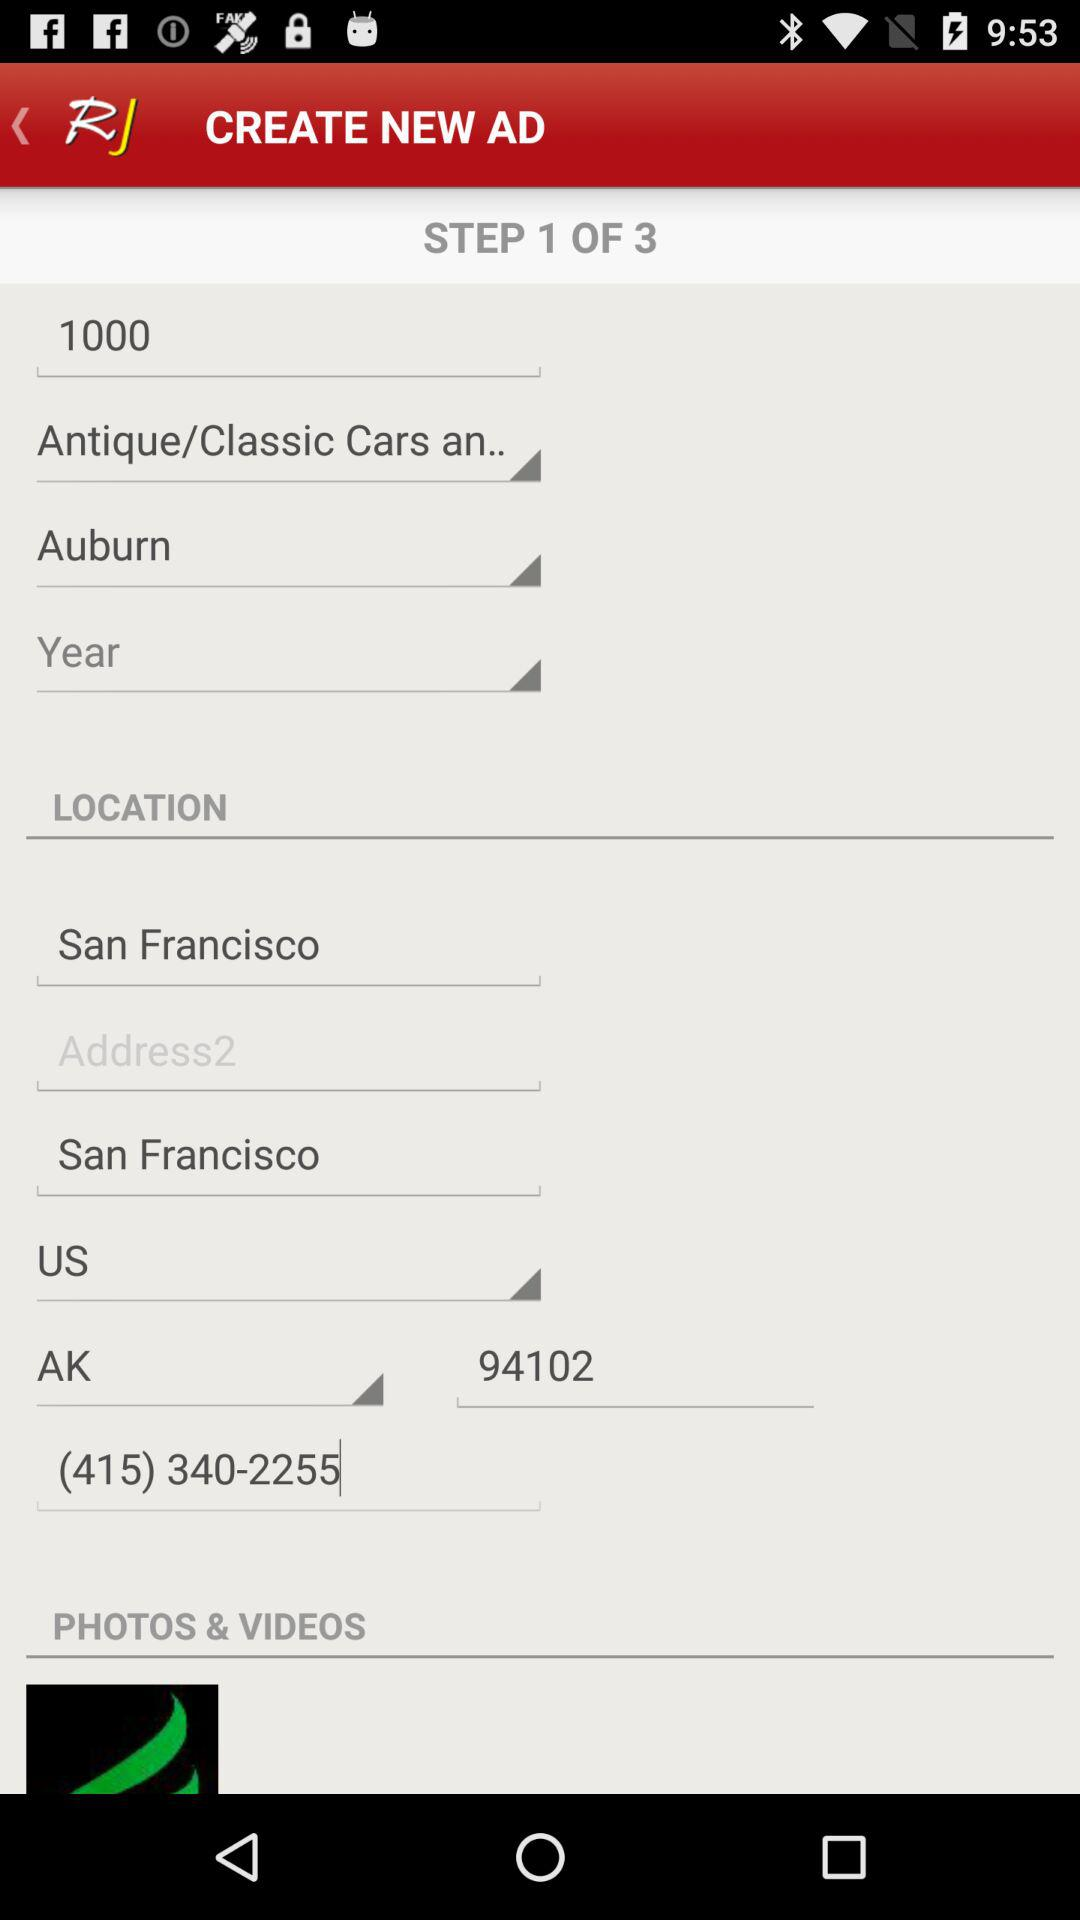What is the phone number? The phone number is (415) 340-2255. 